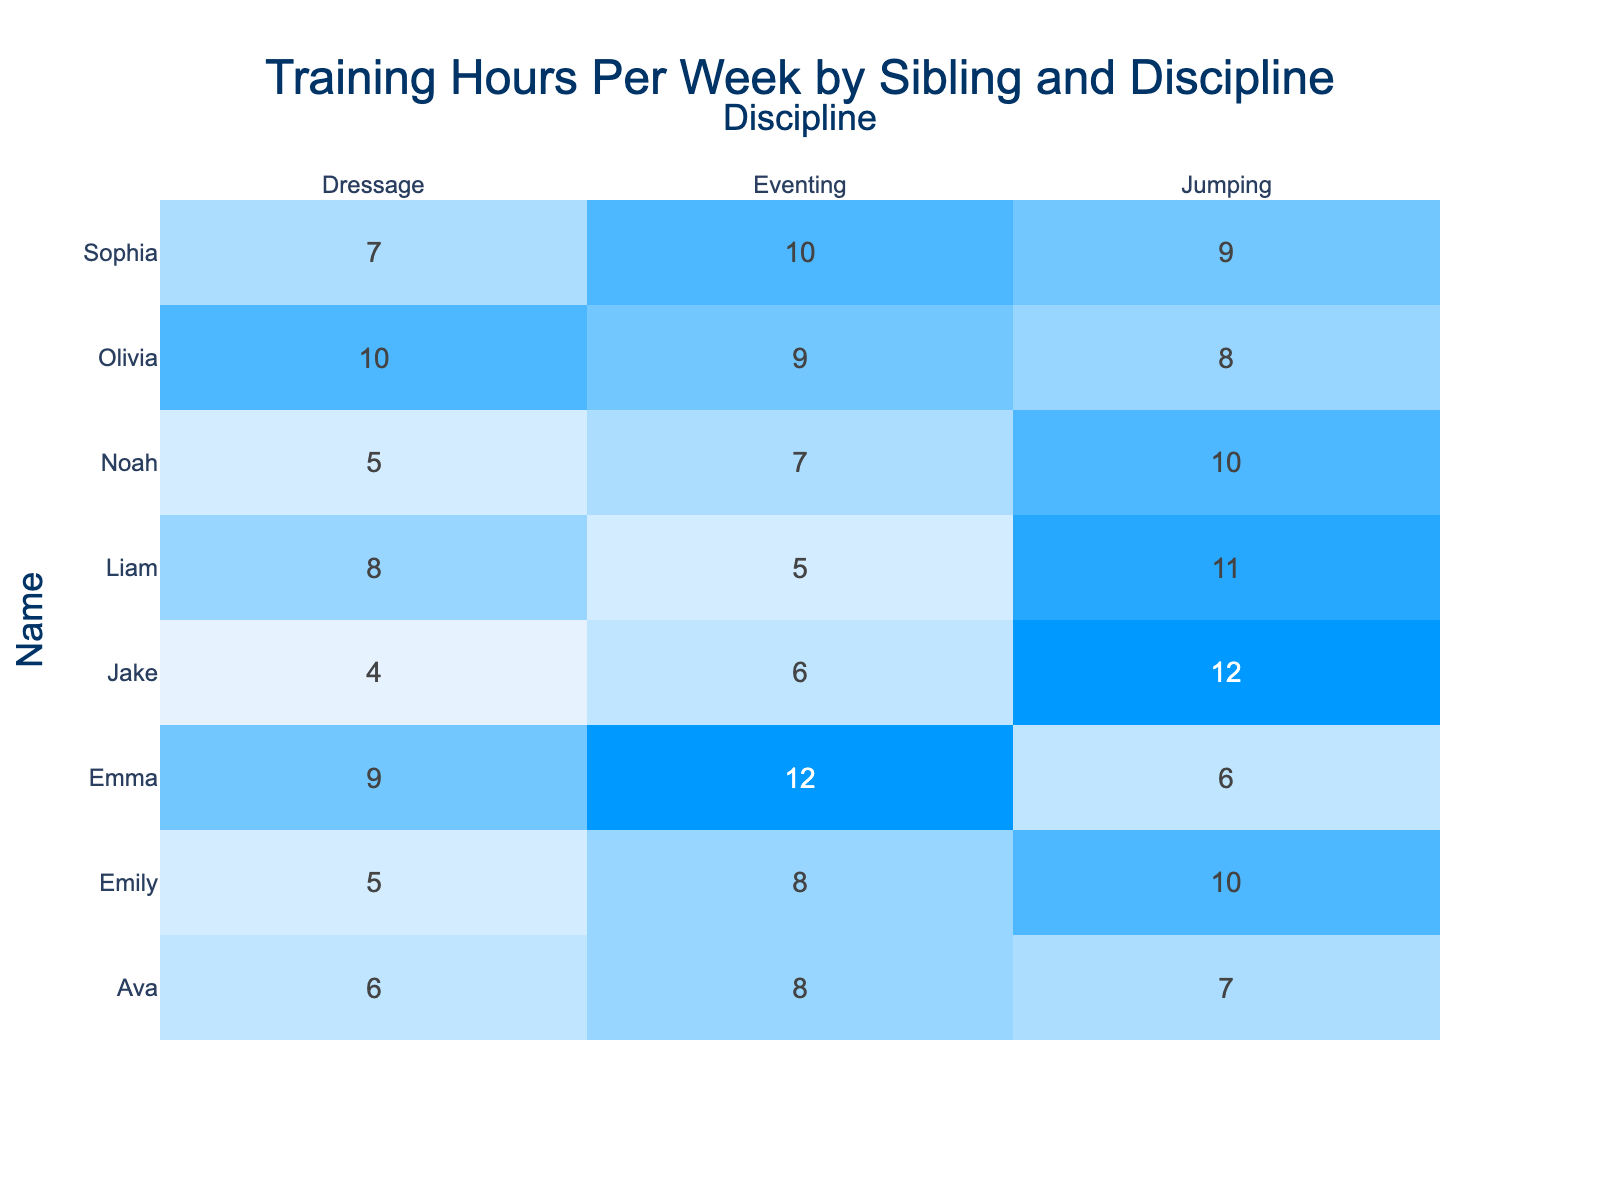What is the maximum number of training hours spent by a sibling in Dressage? The maximum training hours in Dressage can be found by looking through the Dressage row. The values are 5, 4, 7, 8, 9, 5, 10, 6. The maximum among these is 10.
Answer: 10 How many training hours does Liam spend on Jumping? Liam's Jumping training hours are located directly in the Jumping column under Liam's name, which states he spends 11 hours training.
Answer: 11 Who spends the least amount of time training in Eventing? We check the Eventing values, which are 8, 6, 10, 5, 12, 7, 9, 8. The minimum among these values is 5, which corresponds to Liam.
Answer: Liam What is the total training time across all disciplines for Noah? To find Noah's total training hours, add his hours in all disciplines: 10 (Jumping) + 5 (Dressage) + 7 (Eventing) = 22.
Answer: 22 How many siblings train for 10 hours or more in Jumping? The Jumping hours are 10, 12, 9, 11, 6, 10, 10, 8, 7. The values of 10 and above are found for Emily, Jake, Liam, and Noah, which makes four siblings.
Answer: 4 What is the average training time for Sophia across all disciplines? To find the average, sum up Sophia's training hours (9 + 7 + 10 = 26) and divide by the number of disciplines (3), which results in an average of 8.67.
Answer: 8.67 Is Emma training more hours in Dressage than in Jumping? Emma's training hours are 9 in Dressage and 6 in Jumping. Since 9 is greater than 6, the statement is true.
Answer: Yes Which sibling spends the most time in Eventing, and how many hours do they train? The Eventing hours are checked across all siblings: 8, 6, 10, 5, 12, 7, 9, 8. The maximum value is 12, which corresponds to Emma.
Answer: Emma, 12 If you combine Jake's and Olivia's Dressage training hours, what total do you calculate? Jake has 4 hours and Olivia has 10 hours in Dressage. Adding these together gives 4 + 10 = 14 hours.
Answer: 14 Who has the highest total training hours overall, and what is the total? We calculate the total training hours for each sibling, finding the totals: Emily (23), Jake (22), Sophia (26), Liam (24), Emma (27), Noah (22), and Olivia (27). The highest is Emma and Olivia with 27 hours.
Answer: Emma, 27 